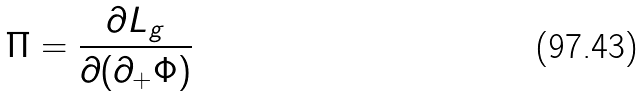Convert formula to latex. <formula><loc_0><loc_0><loc_500><loc_500>\Pi = \frac { \partial L _ { g } } { \partial ( \partial _ { + } \Phi ) }</formula> 